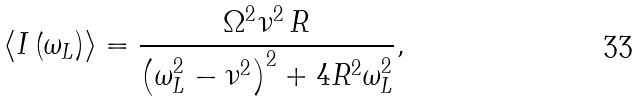<formula> <loc_0><loc_0><loc_500><loc_500>\langle I \left ( \omega _ { L } \right ) \rangle = \frac { { \Omega } ^ { 2 } { \nu } ^ { 2 } \, R } { \left ( \omega _ { L } ^ { 2 } - \nu ^ { 2 } \right ) ^ { 2 } + 4 R ^ { 2 } \omega _ { L } ^ { 2 } } ,</formula> 